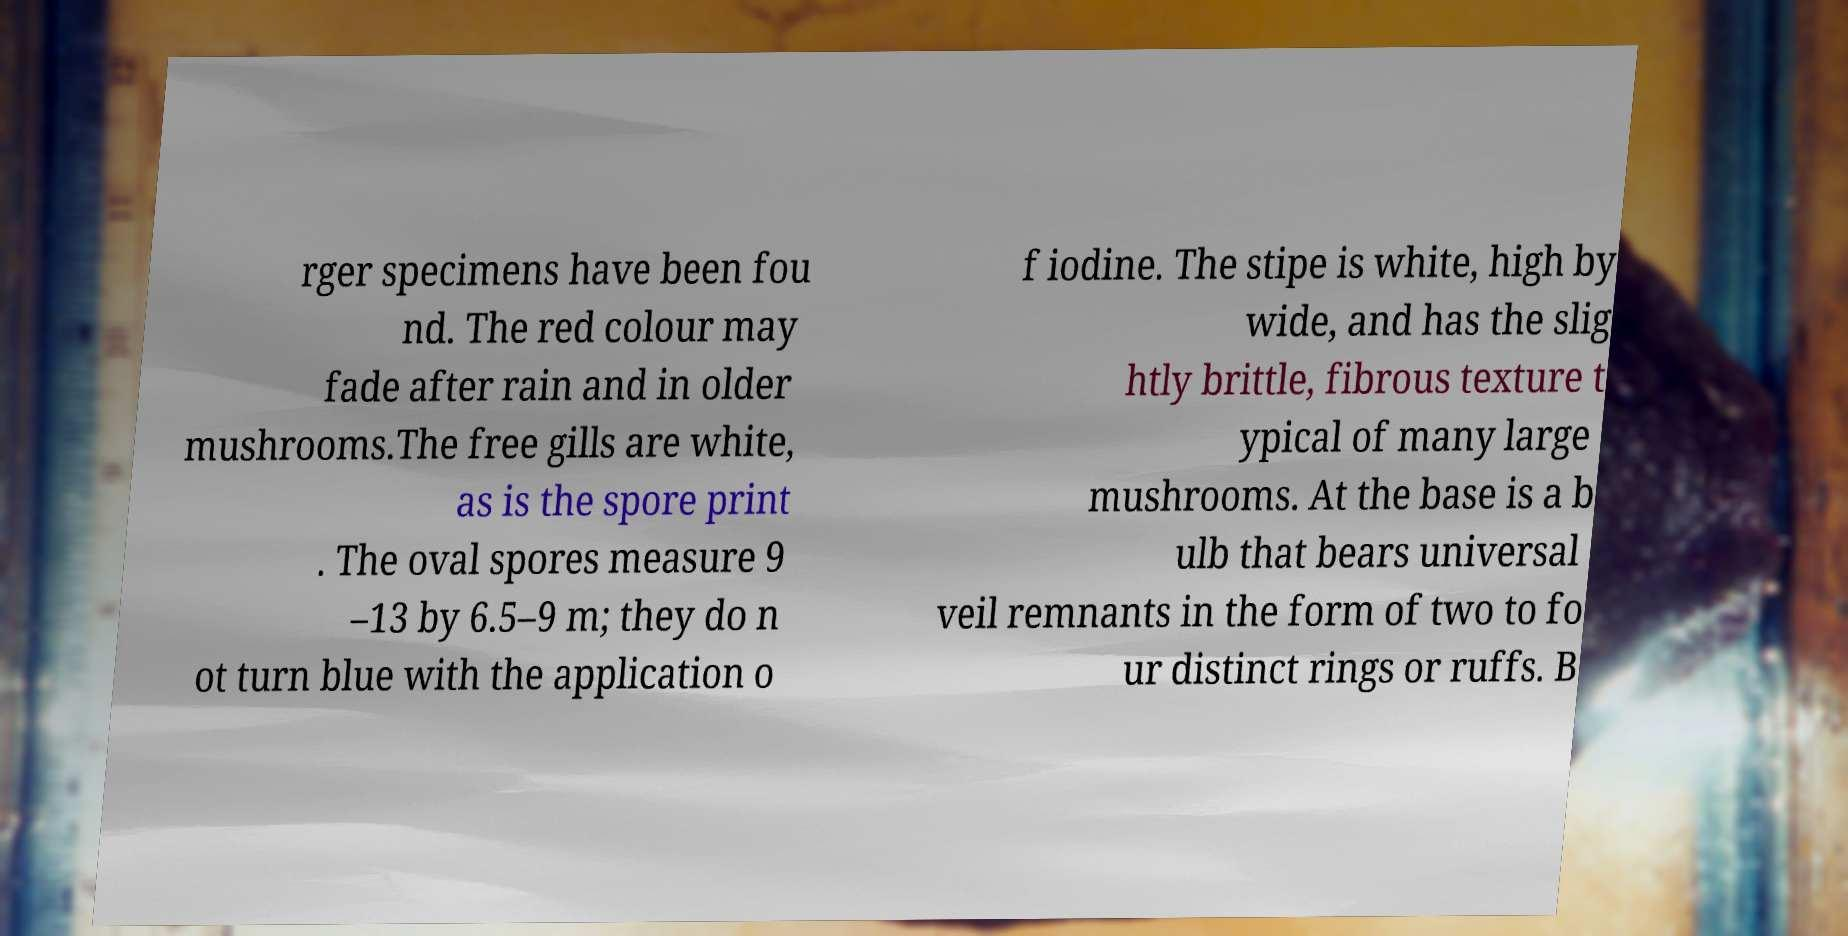Please identify and transcribe the text found in this image. rger specimens have been fou nd. The red colour may fade after rain and in older mushrooms.The free gills are white, as is the spore print . The oval spores measure 9 –13 by 6.5–9 m; they do n ot turn blue with the application o f iodine. The stipe is white, high by wide, and has the slig htly brittle, fibrous texture t ypical of many large mushrooms. At the base is a b ulb that bears universal veil remnants in the form of two to fo ur distinct rings or ruffs. B 